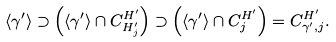Convert formula to latex. <formula><loc_0><loc_0><loc_500><loc_500>\langle \gamma ^ { \prime } \rangle \supset \left ( \langle \gamma ^ { \prime } \rangle \cap C ^ { H ^ { \prime } } _ { H ^ { \prime } _ { j } } \right ) \supset \left ( \langle \gamma ^ { \prime } \rangle \cap C ^ { H ^ { \prime } } _ { j } \right ) = C ^ { H ^ { \prime } } _ { \gamma ^ { \prime } , j } .</formula> 